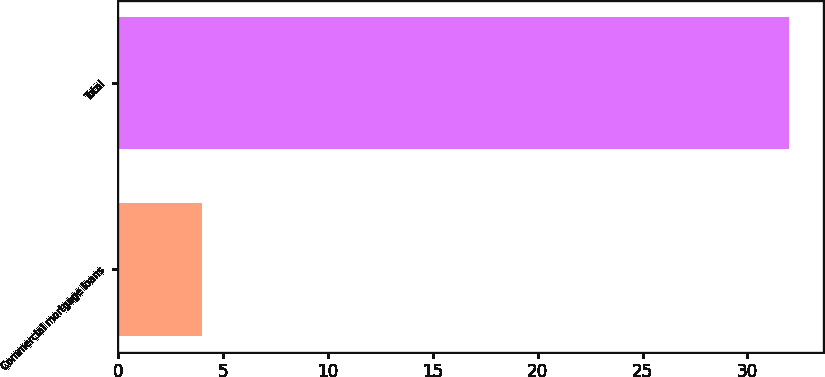<chart> <loc_0><loc_0><loc_500><loc_500><bar_chart><fcel>Commercial mortgage loans<fcel>Total<nl><fcel>4<fcel>32<nl></chart> 